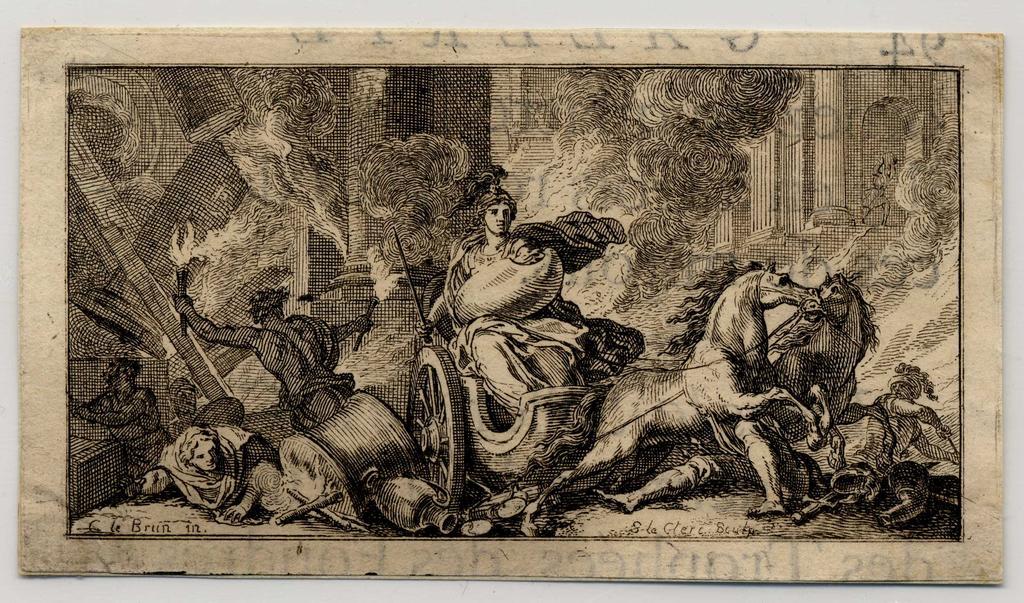Can you describe this image briefly? In this image we can see a photo frame placed on the wall. 